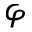Convert formula to latex. <formula><loc_0><loc_0><loc_500><loc_500>\varphi</formula> 